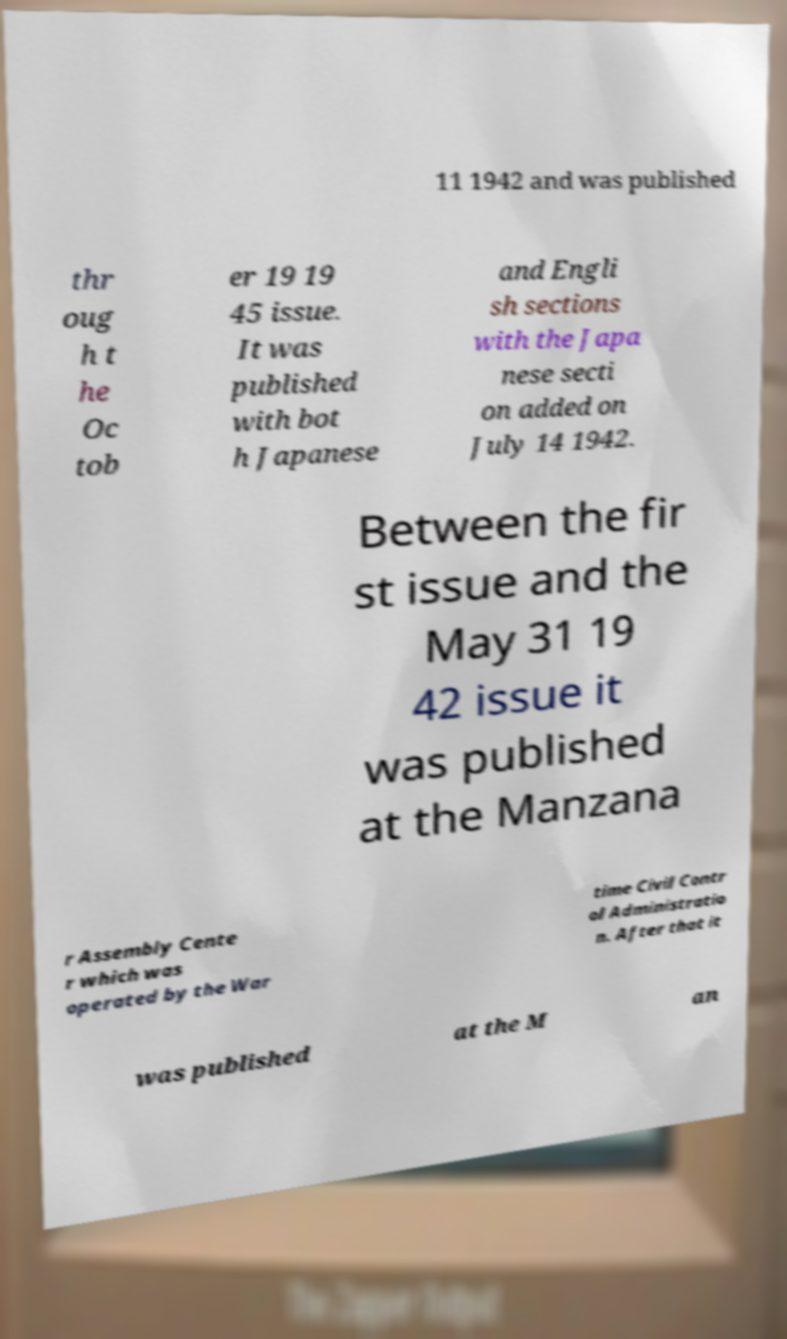What messages or text are displayed in this image? I need them in a readable, typed format. 11 1942 and was published thr oug h t he Oc tob er 19 19 45 issue. It was published with bot h Japanese and Engli sh sections with the Japa nese secti on added on July 14 1942. Between the fir st issue and the May 31 19 42 issue it was published at the Manzana r Assembly Cente r which was operated by the War time Civil Contr ol Administratio n. After that it was published at the M an 